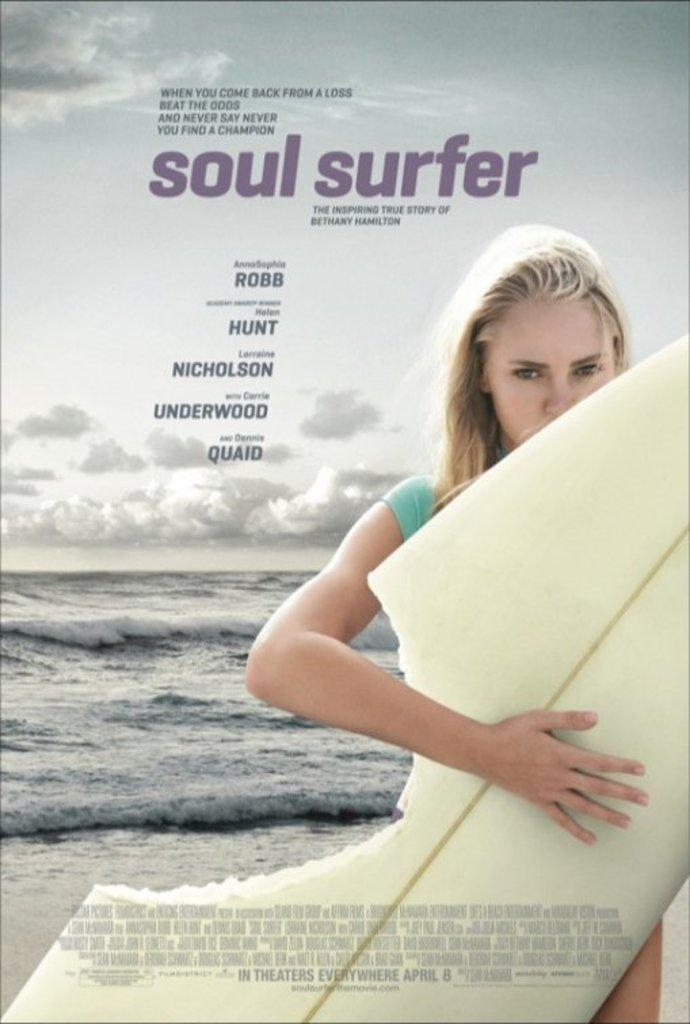What is the main subject of the image? There is a lady person in the image. What is the lady person doing in the image? The lady person is standing and holding a surfing board. What can be seen in the background of the image? There is water and a cloudy sky visible in the background of the image. What type of coastline can be seen in the image? There is no coastline visible in the image. What boundary is present between the water and the sky in the image? There is no boundary between the water and the sky mentioned in the image; it only describes the water and cloudy sky as separate elements in the background. 